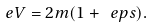Convert formula to latex. <formula><loc_0><loc_0><loc_500><loc_500>e V = 2 m ( 1 + \ e p s ) .</formula> 